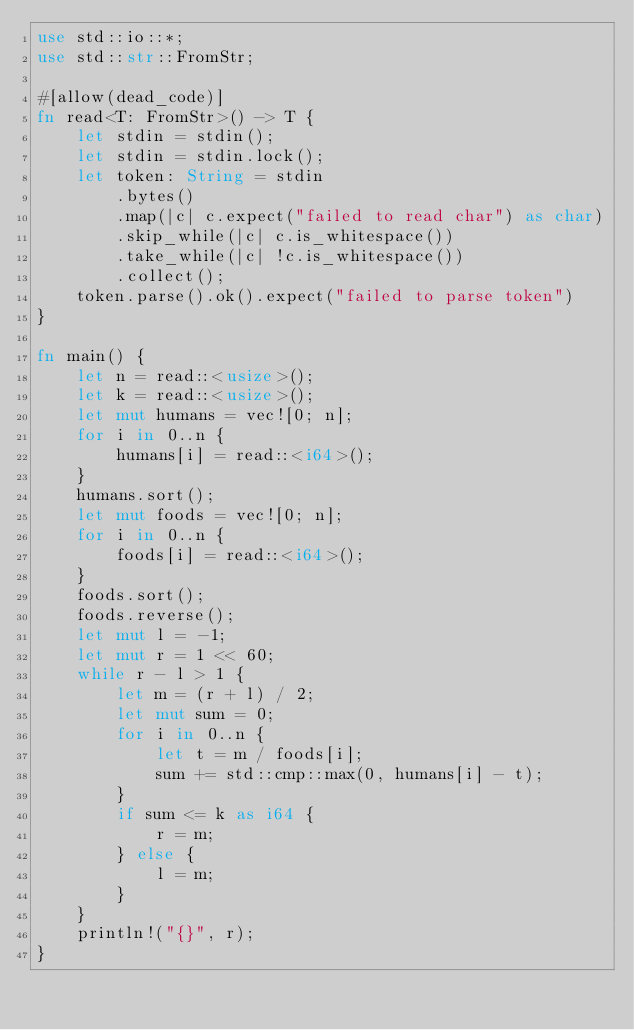<code> <loc_0><loc_0><loc_500><loc_500><_Rust_>use std::io::*;
use std::str::FromStr;

#[allow(dead_code)]
fn read<T: FromStr>() -> T {
    let stdin = stdin();
    let stdin = stdin.lock();
    let token: String = stdin
        .bytes()
        .map(|c| c.expect("failed to read char") as char)
        .skip_while(|c| c.is_whitespace())
        .take_while(|c| !c.is_whitespace())
        .collect();
    token.parse().ok().expect("failed to parse token")
}

fn main() {
    let n = read::<usize>();
    let k = read::<usize>();
    let mut humans = vec![0; n];
    for i in 0..n {
        humans[i] = read::<i64>();
    }
    humans.sort();
    let mut foods = vec![0; n];
    for i in 0..n {
        foods[i] = read::<i64>();
    }
    foods.sort();
    foods.reverse();
    let mut l = -1;
    let mut r = 1 << 60;
    while r - l > 1 {
        let m = (r + l) / 2;
        let mut sum = 0;
        for i in 0..n {
            let t = m / foods[i];
            sum += std::cmp::max(0, humans[i] - t);
        }
        if sum <= k as i64 {
            r = m;
        } else {
            l = m;
        }
    }
    println!("{}", r);
}
</code> 